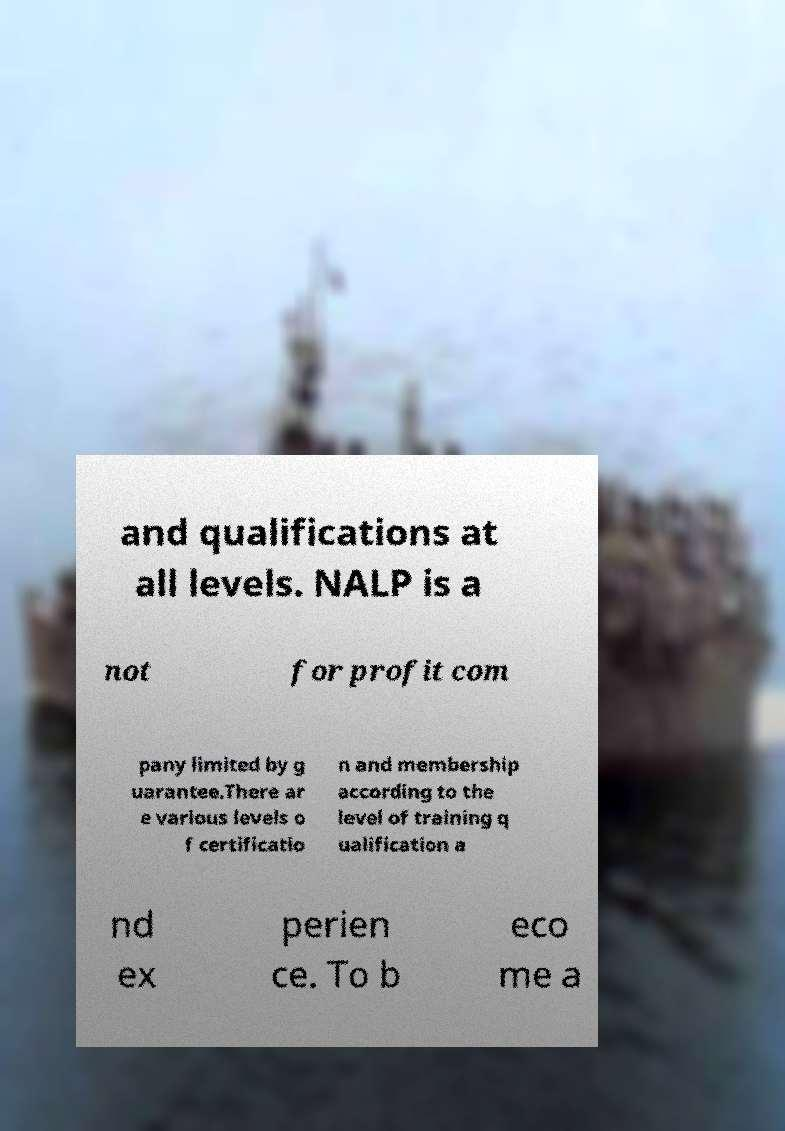What messages or text are displayed in this image? I need them in a readable, typed format. and qualifications at all levels. NALP is a not for profit com pany limited by g uarantee.There ar e various levels o f certificatio n and membership according to the level of training q ualification a nd ex perien ce. To b eco me a 